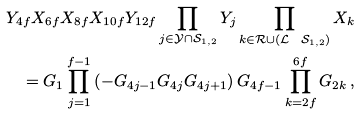Convert formula to latex. <formula><loc_0><loc_0><loc_500><loc_500>Y _ { 4 f } X _ { 6 f } X _ { 8 f } X _ { 1 0 f } Y _ { 1 2 f } \prod _ { j \in \mathcal { Y } \cap \mathcal { S } _ { 1 , 2 } } Y _ { j } \prod _ { k \in \mathcal { R } \cup ( \mathcal { L } \ \mathcal { S } _ { 1 , 2 } ) } X _ { k } \\ = G _ { 1 } \prod _ { j = 1 } ^ { f - 1 } \left ( - G _ { 4 j - 1 } G _ { 4 j } G _ { 4 j + 1 } \right ) G _ { 4 f - 1 } \prod _ { k = 2 f } ^ { 6 f } G _ { 2 k } \, ,</formula> 